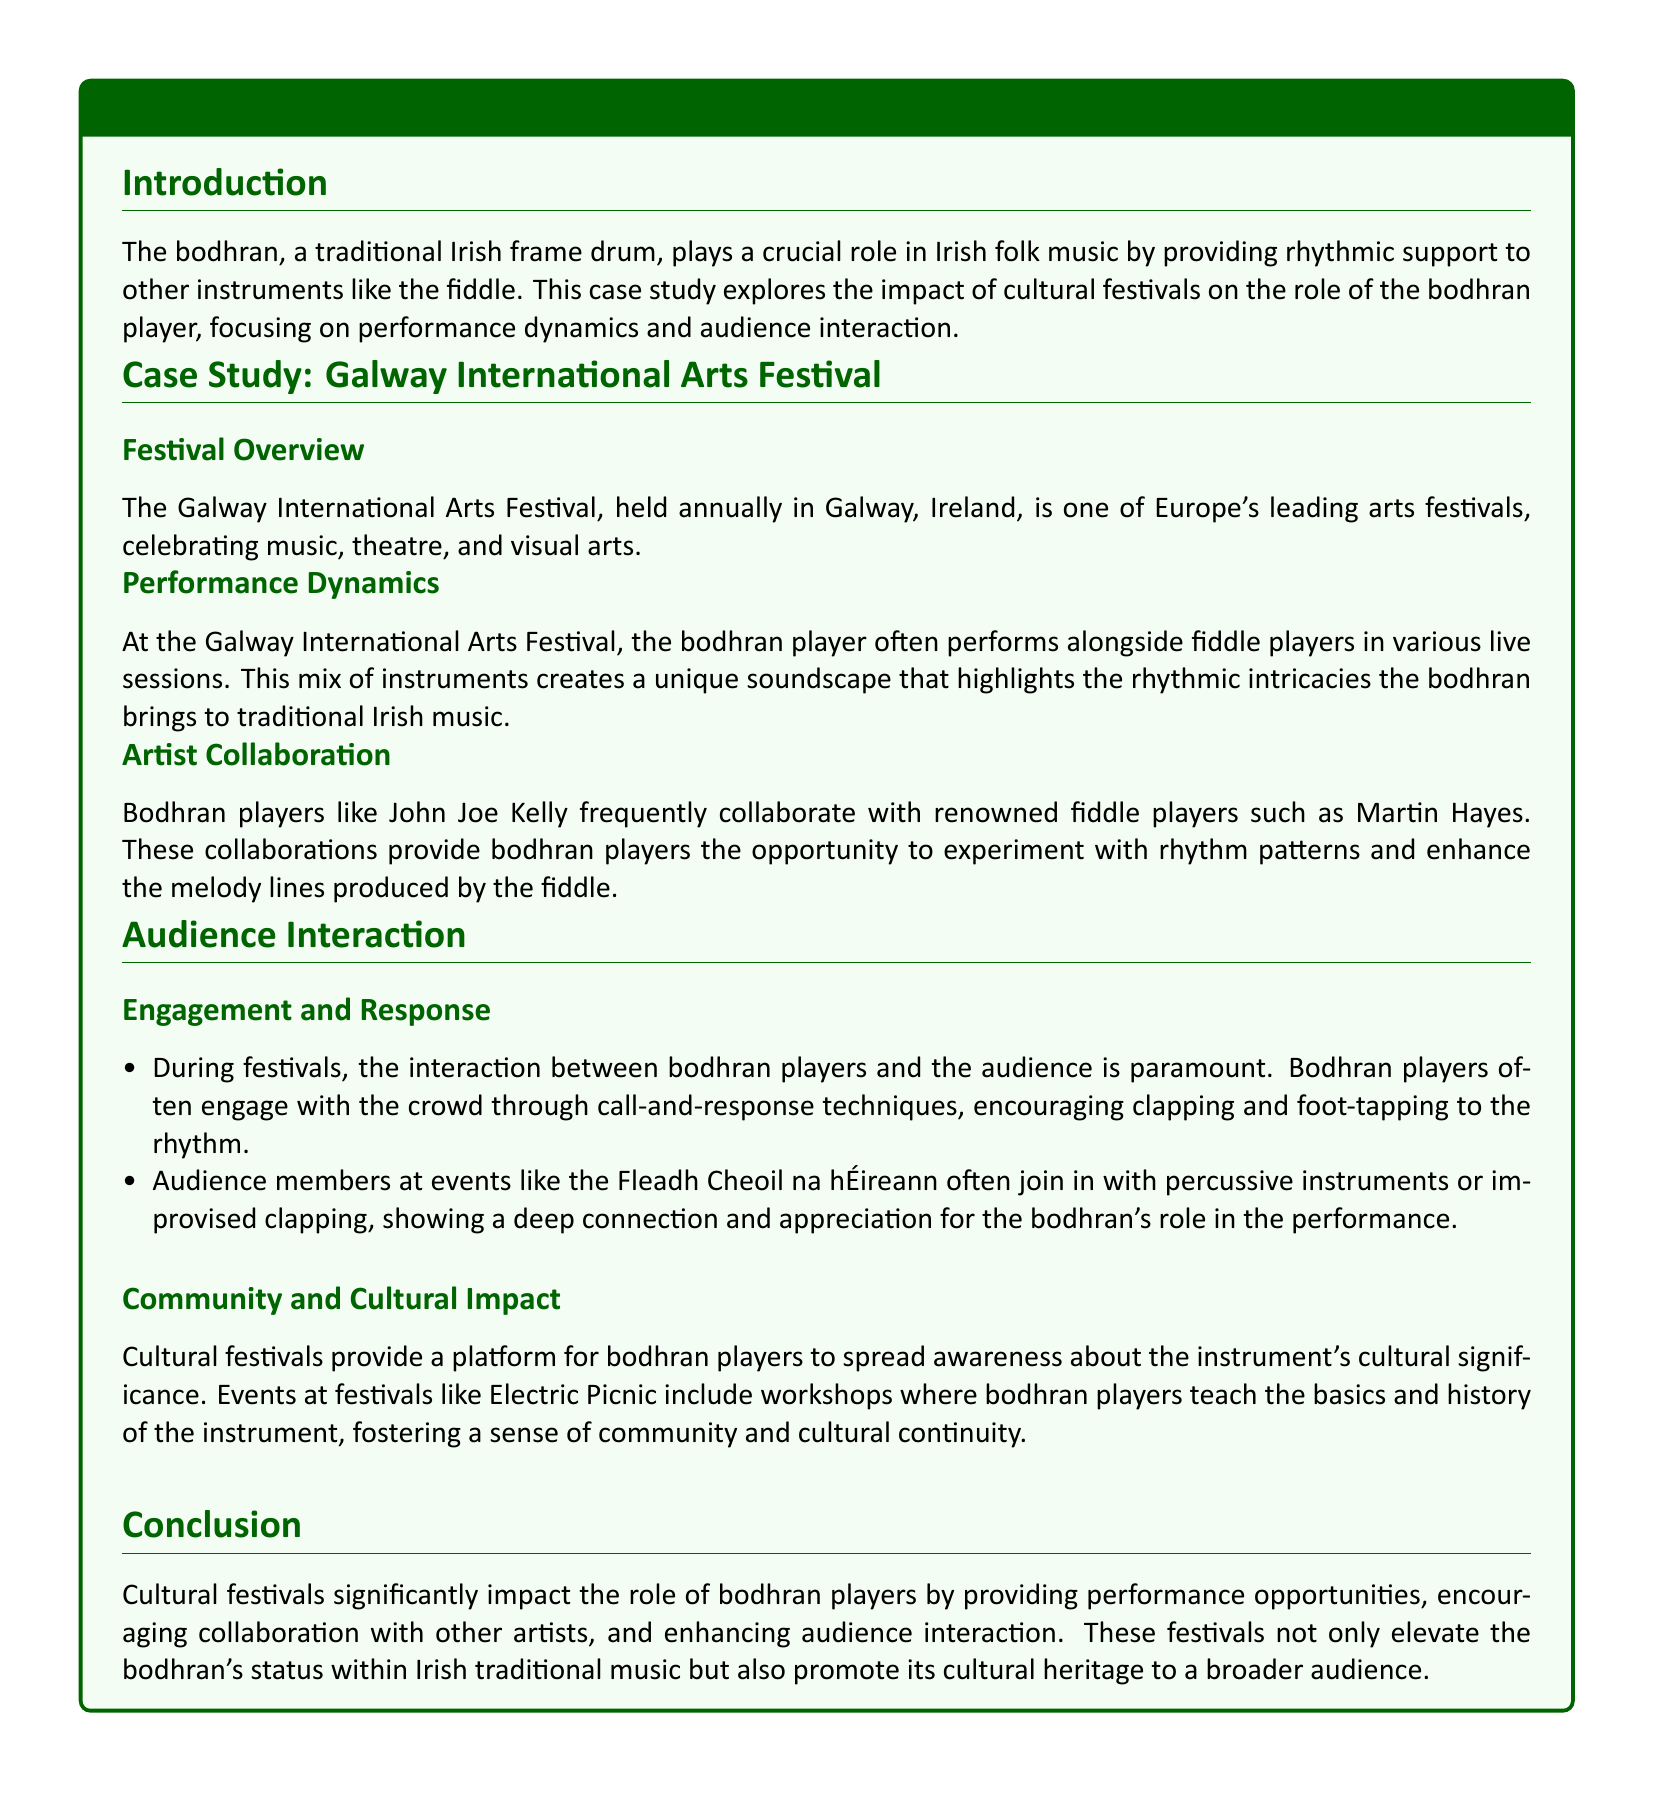What is the name of the festival discussed in the case study? The festival discussed is the Galway International Arts Festival, which is highlighted in the case study.
Answer: Galway International Arts Festival Who is a renowned fiddle player that collaborates with bodhran players? The document mentions Martin Hayes as a renowned fiddle player collaborating with bodhran players.
Answer: Martin Hayes What technique do bodhran players use to engage the audience? Bodhran players often use call-and-response techniques to engage with the audience during performances.
Answer: Call-and-response What type of instrument is a bodhran? The bodhran is described as a traditional Irish frame drum in the case study.
Answer: Traditional Irish frame drum Which festival includes workshops for teaching the bodhran? The document states that Electric Picnic features workshops where bodhran players teach about the instrument.
Answer: Electric Picnic How do audience members often participate during performances? Audience members often join in with percussive instruments or improvised clapping, showing their engagement with the performance.
Answer: Percussion or clapping What role does the bodhran play in Irish folk music? The bodhran provides rhythmic support to other instruments like the fiddle, as indicated in the case study.
Answer: Rhythmic support How do cultural festivals impact bodhran players? Cultural festivals provide performance opportunities, encourage collaboration, and enhance audience interaction for bodhran players, as stated in the conclusion.
Answer: Performance opportunities What is one of the main focuses of the case study? The main focus of the case study is the impact of cultural festivals on the role of the bodhran player.
Answer: Impact of cultural festivals 